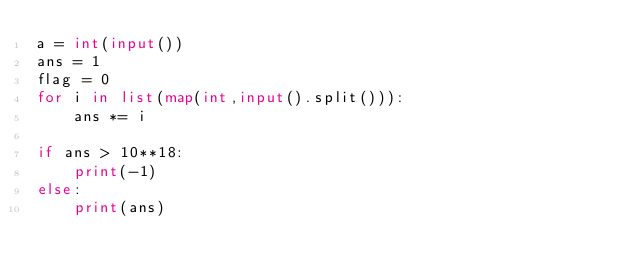<code> <loc_0><loc_0><loc_500><loc_500><_Python_>a = int(input())
ans = 1
flag = 0
for i in list(map(int,input().split())):
    ans *= i
    
if ans > 10**18:
    print(-1)
else:
    print(ans)</code> 